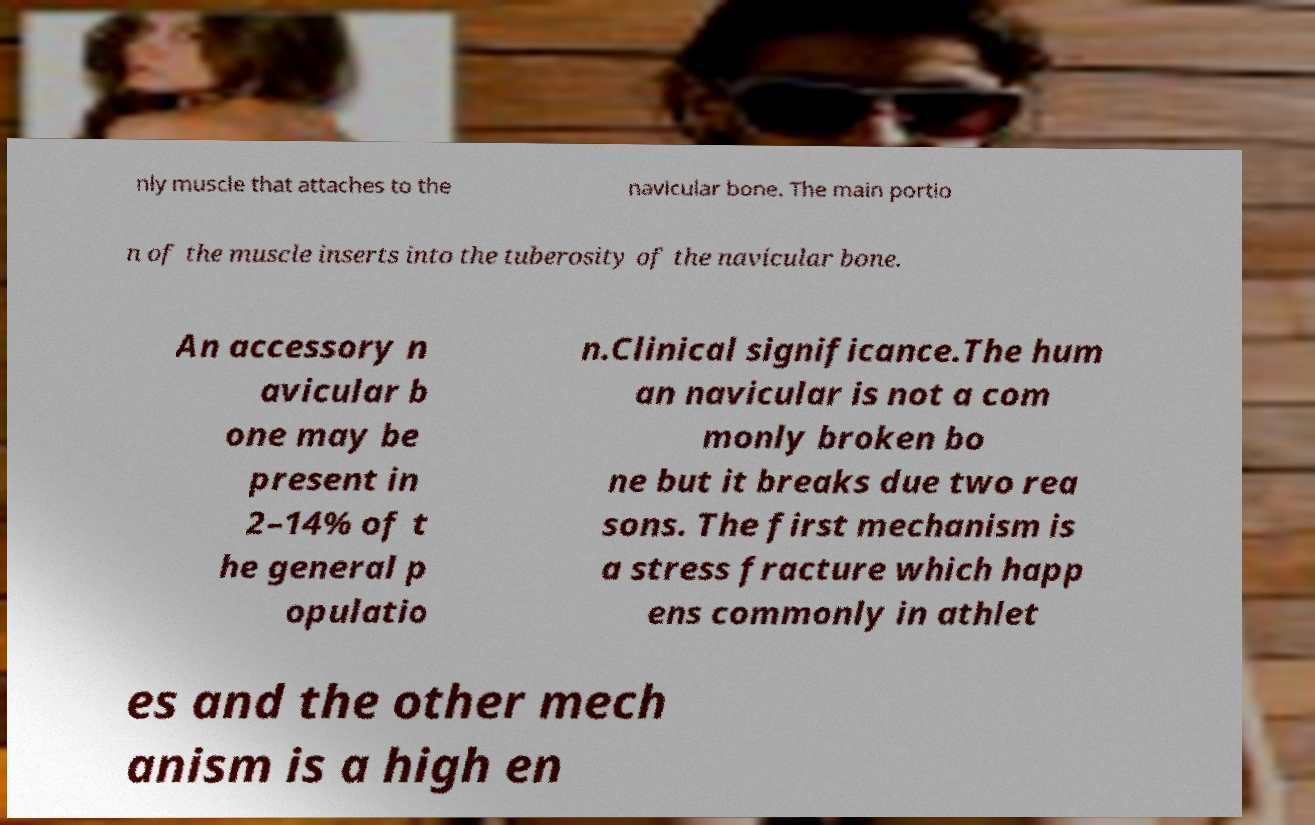I need the written content from this picture converted into text. Can you do that? nly muscle that attaches to the navicular bone. The main portio n of the muscle inserts into the tuberosity of the navicular bone. An accessory n avicular b one may be present in 2–14% of t he general p opulatio n.Clinical significance.The hum an navicular is not a com monly broken bo ne but it breaks due two rea sons. The first mechanism is a stress fracture which happ ens commonly in athlet es and the other mech anism is a high en 